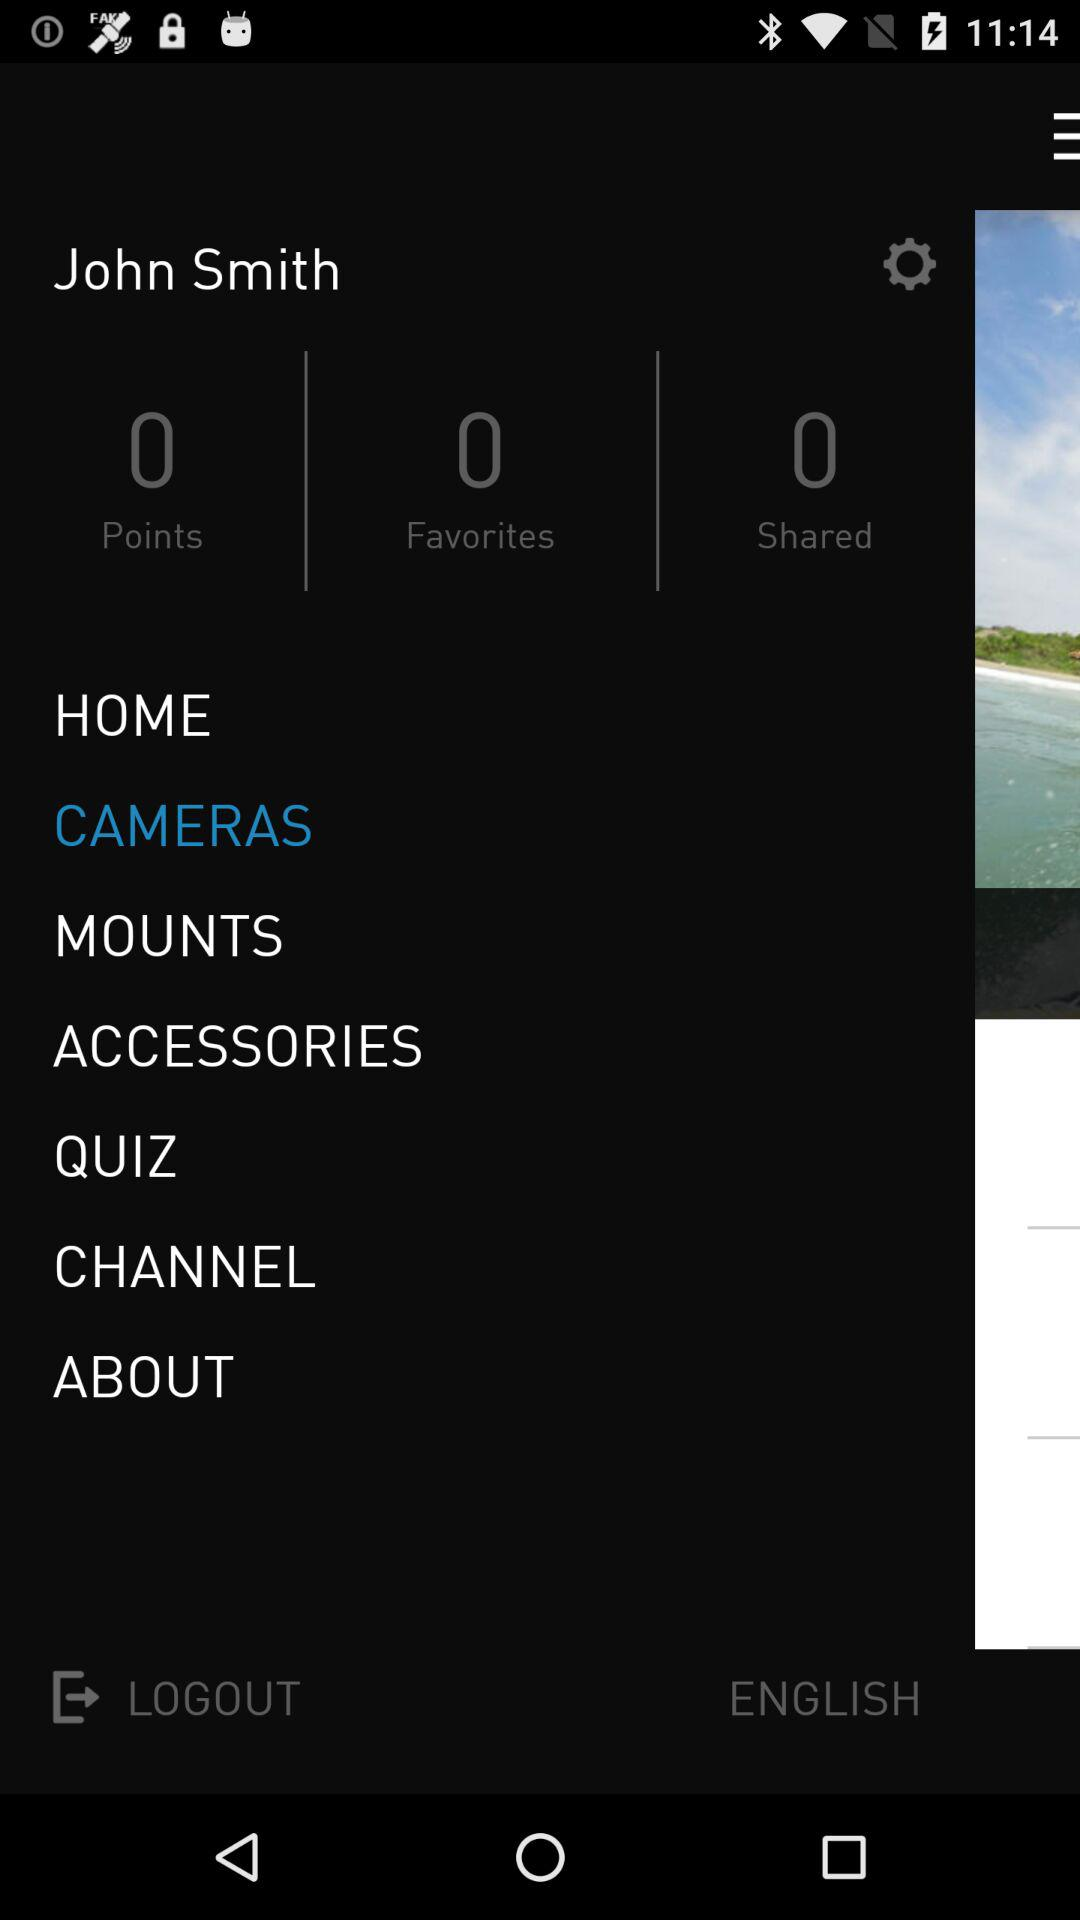What is the user name? The user name is John Smith. 